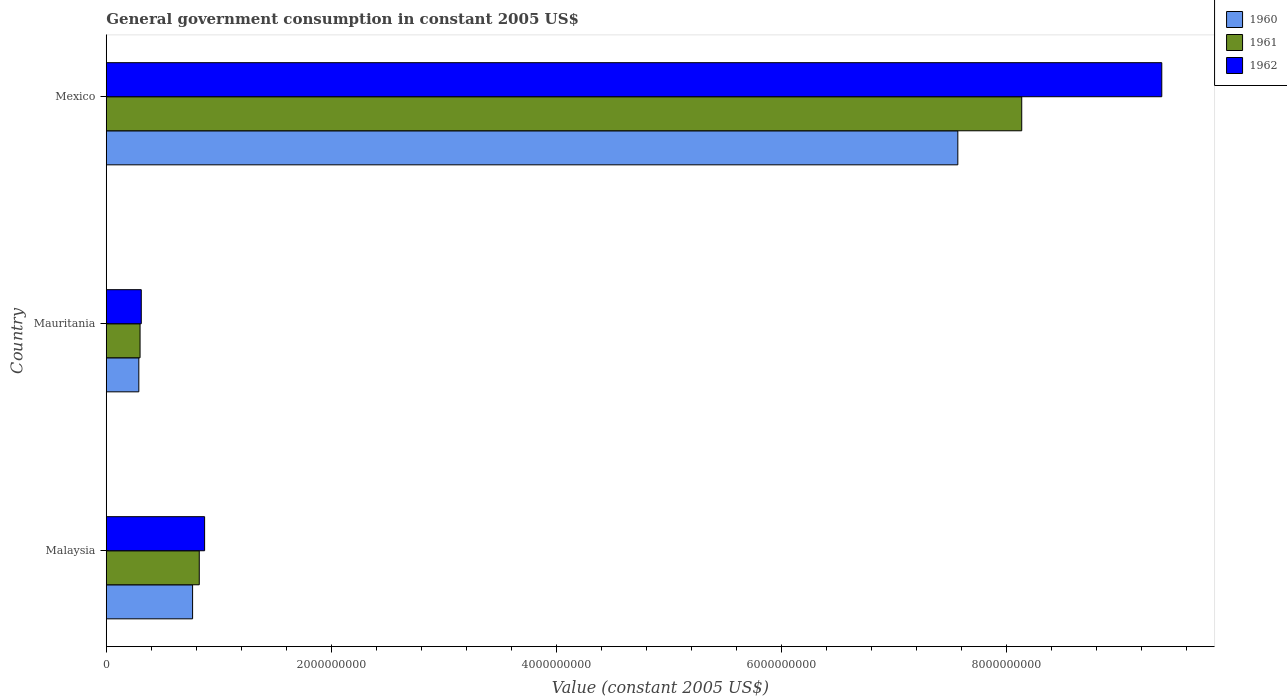Are the number of bars on each tick of the Y-axis equal?
Your answer should be very brief. Yes. How many bars are there on the 2nd tick from the top?
Give a very brief answer. 3. How many bars are there on the 3rd tick from the bottom?
Give a very brief answer. 3. What is the label of the 1st group of bars from the top?
Provide a succinct answer. Mexico. In how many cases, is the number of bars for a given country not equal to the number of legend labels?
Provide a succinct answer. 0. What is the government conusmption in 1962 in Mexico?
Give a very brief answer. 9.38e+09. Across all countries, what is the maximum government conusmption in 1960?
Your response must be concise. 7.57e+09. Across all countries, what is the minimum government conusmption in 1960?
Provide a succinct answer. 2.89e+08. In which country was the government conusmption in 1961 maximum?
Your response must be concise. Mexico. In which country was the government conusmption in 1962 minimum?
Ensure brevity in your answer.  Mauritania. What is the total government conusmption in 1961 in the graph?
Your answer should be very brief. 9.26e+09. What is the difference between the government conusmption in 1961 in Malaysia and that in Mexico?
Your answer should be very brief. -7.31e+09. What is the difference between the government conusmption in 1960 in Mauritania and the government conusmption in 1961 in Mexico?
Make the answer very short. -7.85e+09. What is the average government conusmption in 1961 per country?
Your answer should be compact. 3.09e+09. What is the difference between the government conusmption in 1961 and government conusmption in 1962 in Malaysia?
Offer a terse response. -4.75e+07. What is the ratio of the government conusmption in 1961 in Malaysia to that in Mexico?
Offer a terse response. 0.1. What is the difference between the highest and the second highest government conusmption in 1961?
Offer a terse response. 7.31e+09. What is the difference between the highest and the lowest government conusmption in 1960?
Your answer should be very brief. 7.28e+09. In how many countries, is the government conusmption in 1962 greater than the average government conusmption in 1962 taken over all countries?
Your answer should be very brief. 1. Is the sum of the government conusmption in 1961 in Malaysia and Mauritania greater than the maximum government conusmption in 1960 across all countries?
Provide a succinct answer. No. What does the 3rd bar from the top in Malaysia represents?
Make the answer very short. 1960. Is it the case that in every country, the sum of the government conusmption in 1961 and government conusmption in 1960 is greater than the government conusmption in 1962?
Offer a very short reply. Yes. Are all the bars in the graph horizontal?
Make the answer very short. Yes. How many countries are there in the graph?
Your answer should be compact. 3. Are the values on the major ticks of X-axis written in scientific E-notation?
Keep it short and to the point. No. Does the graph contain any zero values?
Your answer should be compact. No. Does the graph contain grids?
Provide a short and direct response. No. How are the legend labels stacked?
Your response must be concise. Vertical. What is the title of the graph?
Ensure brevity in your answer.  General government consumption in constant 2005 US$. Does "1978" appear as one of the legend labels in the graph?
Your answer should be compact. No. What is the label or title of the X-axis?
Give a very brief answer. Value (constant 2005 US$). What is the label or title of the Y-axis?
Give a very brief answer. Country. What is the Value (constant 2005 US$) of 1960 in Malaysia?
Ensure brevity in your answer.  7.67e+08. What is the Value (constant 2005 US$) in 1961 in Malaysia?
Provide a short and direct response. 8.26e+08. What is the Value (constant 2005 US$) of 1962 in Malaysia?
Make the answer very short. 8.74e+08. What is the Value (constant 2005 US$) of 1960 in Mauritania?
Give a very brief answer. 2.89e+08. What is the Value (constant 2005 US$) in 1961 in Mauritania?
Offer a very short reply. 3.00e+08. What is the Value (constant 2005 US$) in 1962 in Mauritania?
Your response must be concise. 3.11e+08. What is the Value (constant 2005 US$) of 1960 in Mexico?
Provide a succinct answer. 7.57e+09. What is the Value (constant 2005 US$) in 1961 in Mexico?
Your answer should be very brief. 8.13e+09. What is the Value (constant 2005 US$) in 1962 in Mexico?
Offer a terse response. 9.38e+09. Across all countries, what is the maximum Value (constant 2005 US$) of 1960?
Keep it short and to the point. 7.57e+09. Across all countries, what is the maximum Value (constant 2005 US$) of 1961?
Provide a succinct answer. 8.13e+09. Across all countries, what is the maximum Value (constant 2005 US$) of 1962?
Your answer should be very brief. 9.38e+09. Across all countries, what is the minimum Value (constant 2005 US$) of 1960?
Make the answer very short. 2.89e+08. Across all countries, what is the minimum Value (constant 2005 US$) in 1961?
Keep it short and to the point. 3.00e+08. Across all countries, what is the minimum Value (constant 2005 US$) of 1962?
Provide a succinct answer. 3.11e+08. What is the total Value (constant 2005 US$) in 1960 in the graph?
Offer a very short reply. 8.62e+09. What is the total Value (constant 2005 US$) in 1961 in the graph?
Your answer should be compact. 9.26e+09. What is the total Value (constant 2005 US$) of 1962 in the graph?
Make the answer very short. 1.06e+1. What is the difference between the Value (constant 2005 US$) in 1960 in Malaysia and that in Mauritania?
Offer a very short reply. 4.78e+08. What is the difference between the Value (constant 2005 US$) of 1961 in Malaysia and that in Mauritania?
Provide a short and direct response. 5.26e+08. What is the difference between the Value (constant 2005 US$) in 1962 in Malaysia and that in Mauritania?
Keep it short and to the point. 5.63e+08. What is the difference between the Value (constant 2005 US$) of 1960 in Malaysia and that in Mexico?
Give a very brief answer. -6.80e+09. What is the difference between the Value (constant 2005 US$) in 1961 in Malaysia and that in Mexico?
Offer a terse response. -7.31e+09. What is the difference between the Value (constant 2005 US$) in 1962 in Malaysia and that in Mexico?
Provide a succinct answer. -8.50e+09. What is the difference between the Value (constant 2005 US$) in 1960 in Mauritania and that in Mexico?
Make the answer very short. -7.28e+09. What is the difference between the Value (constant 2005 US$) in 1961 in Mauritania and that in Mexico?
Your answer should be compact. -7.83e+09. What is the difference between the Value (constant 2005 US$) in 1962 in Mauritania and that in Mexico?
Your answer should be compact. -9.07e+09. What is the difference between the Value (constant 2005 US$) of 1960 in Malaysia and the Value (constant 2005 US$) of 1961 in Mauritania?
Provide a short and direct response. 4.67e+08. What is the difference between the Value (constant 2005 US$) of 1960 in Malaysia and the Value (constant 2005 US$) of 1962 in Mauritania?
Keep it short and to the point. 4.56e+08. What is the difference between the Value (constant 2005 US$) in 1961 in Malaysia and the Value (constant 2005 US$) in 1962 in Mauritania?
Provide a succinct answer. 5.15e+08. What is the difference between the Value (constant 2005 US$) of 1960 in Malaysia and the Value (constant 2005 US$) of 1961 in Mexico?
Ensure brevity in your answer.  -7.37e+09. What is the difference between the Value (constant 2005 US$) in 1960 in Malaysia and the Value (constant 2005 US$) in 1962 in Mexico?
Provide a succinct answer. -8.61e+09. What is the difference between the Value (constant 2005 US$) in 1961 in Malaysia and the Value (constant 2005 US$) in 1962 in Mexico?
Make the answer very short. -8.55e+09. What is the difference between the Value (constant 2005 US$) in 1960 in Mauritania and the Value (constant 2005 US$) in 1961 in Mexico?
Your answer should be compact. -7.85e+09. What is the difference between the Value (constant 2005 US$) in 1960 in Mauritania and the Value (constant 2005 US$) in 1962 in Mexico?
Your answer should be compact. -9.09e+09. What is the difference between the Value (constant 2005 US$) of 1961 in Mauritania and the Value (constant 2005 US$) of 1962 in Mexico?
Your answer should be very brief. -9.08e+09. What is the average Value (constant 2005 US$) in 1960 per country?
Ensure brevity in your answer.  2.87e+09. What is the average Value (constant 2005 US$) of 1961 per country?
Offer a terse response. 3.09e+09. What is the average Value (constant 2005 US$) in 1962 per country?
Give a very brief answer. 3.52e+09. What is the difference between the Value (constant 2005 US$) in 1960 and Value (constant 2005 US$) in 1961 in Malaysia?
Your response must be concise. -5.92e+07. What is the difference between the Value (constant 2005 US$) of 1960 and Value (constant 2005 US$) of 1962 in Malaysia?
Offer a very short reply. -1.07e+08. What is the difference between the Value (constant 2005 US$) in 1961 and Value (constant 2005 US$) in 1962 in Malaysia?
Offer a terse response. -4.75e+07. What is the difference between the Value (constant 2005 US$) of 1960 and Value (constant 2005 US$) of 1961 in Mauritania?
Keep it short and to the point. -1.09e+07. What is the difference between the Value (constant 2005 US$) in 1960 and Value (constant 2005 US$) in 1962 in Mauritania?
Provide a short and direct response. -2.18e+07. What is the difference between the Value (constant 2005 US$) of 1961 and Value (constant 2005 US$) of 1962 in Mauritania?
Ensure brevity in your answer.  -1.09e+07. What is the difference between the Value (constant 2005 US$) in 1960 and Value (constant 2005 US$) in 1961 in Mexico?
Provide a short and direct response. -5.68e+08. What is the difference between the Value (constant 2005 US$) of 1960 and Value (constant 2005 US$) of 1962 in Mexico?
Your answer should be compact. -1.81e+09. What is the difference between the Value (constant 2005 US$) of 1961 and Value (constant 2005 US$) of 1962 in Mexico?
Provide a succinct answer. -1.24e+09. What is the ratio of the Value (constant 2005 US$) in 1960 in Malaysia to that in Mauritania?
Make the answer very short. 2.65. What is the ratio of the Value (constant 2005 US$) in 1961 in Malaysia to that in Mauritania?
Keep it short and to the point. 2.75. What is the ratio of the Value (constant 2005 US$) in 1962 in Malaysia to that in Mauritania?
Your answer should be compact. 2.81. What is the ratio of the Value (constant 2005 US$) of 1960 in Malaysia to that in Mexico?
Your response must be concise. 0.1. What is the ratio of the Value (constant 2005 US$) of 1961 in Malaysia to that in Mexico?
Your answer should be very brief. 0.1. What is the ratio of the Value (constant 2005 US$) in 1962 in Malaysia to that in Mexico?
Make the answer very short. 0.09. What is the ratio of the Value (constant 2005 US$) in 1960 in Mauritania to that in Mexico?
Your answer should be very brief. 0.04. What is the ratio of the Value (constant 2005 US$) of 1961 in Mauritania to that in Mexico?
Offer a very short reply. 0.04. What is the ratio of the Value (constant 2005 US$) of 1962 in Mauritania to that in Mexico?
Ensure brevity in your answer.  0.03. What is the difference between the highest and the second highest Value (constant 2005 US$) of 1960?
Offer a terse response. 6.80e+09. What is the difference between the highest and the second highest Value (constant 2005 US$) of 1961?
Offer a terse response. 7.31e+09. What is the difference between the highest and the second highest Value (constant 2005 US$) in 1962?
Keep it short and to the point. 8.50e+09. What is the difference between the highest and the lowest Value (constant 2005 US$) of 1960?
Provide a short and direct response. 7.28e+09. What is the difference between the highest and the lowest Value (constant 2005 US$) of 1961?
Provide a short and direct response. 7.83e+09. What is the difference between the highest and the lowest Value (constant 2005 US$) in 1962?
Your response must be concise. 9.07e+09. 